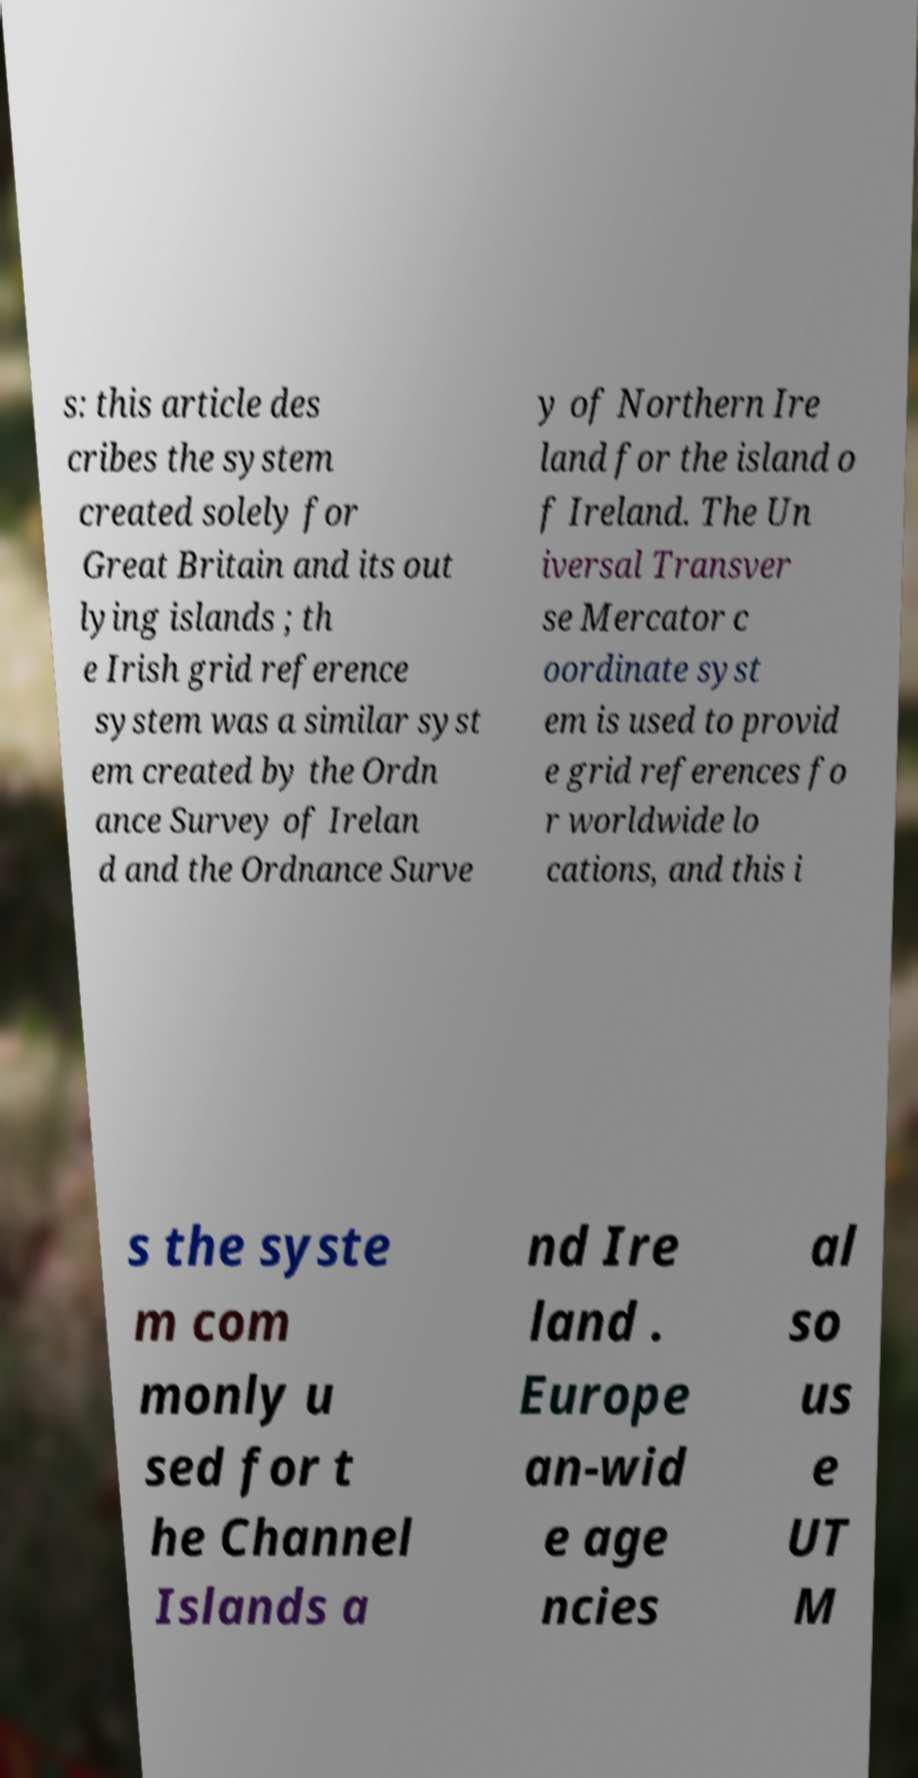What messages or text are displayed in this image? I need them in a readable, typed format. s: this article des cribes the system created solely for Great Britain and its out lying islands ; th e Irish grid reference system was a similar syst em created by the Ordn ance Survey of Irelan d and the Ordnance Surve y of Northern Ire land for the island o f Ireland. The Un iversal Transver se Mercator c oordinate syst em is used to provid e grid references fo r worldwide lo cations, and this i s the syste m com monly u sed for t he Channel Islands a nd Ire land . Europe an-wid e age ncies al so us e UT M 